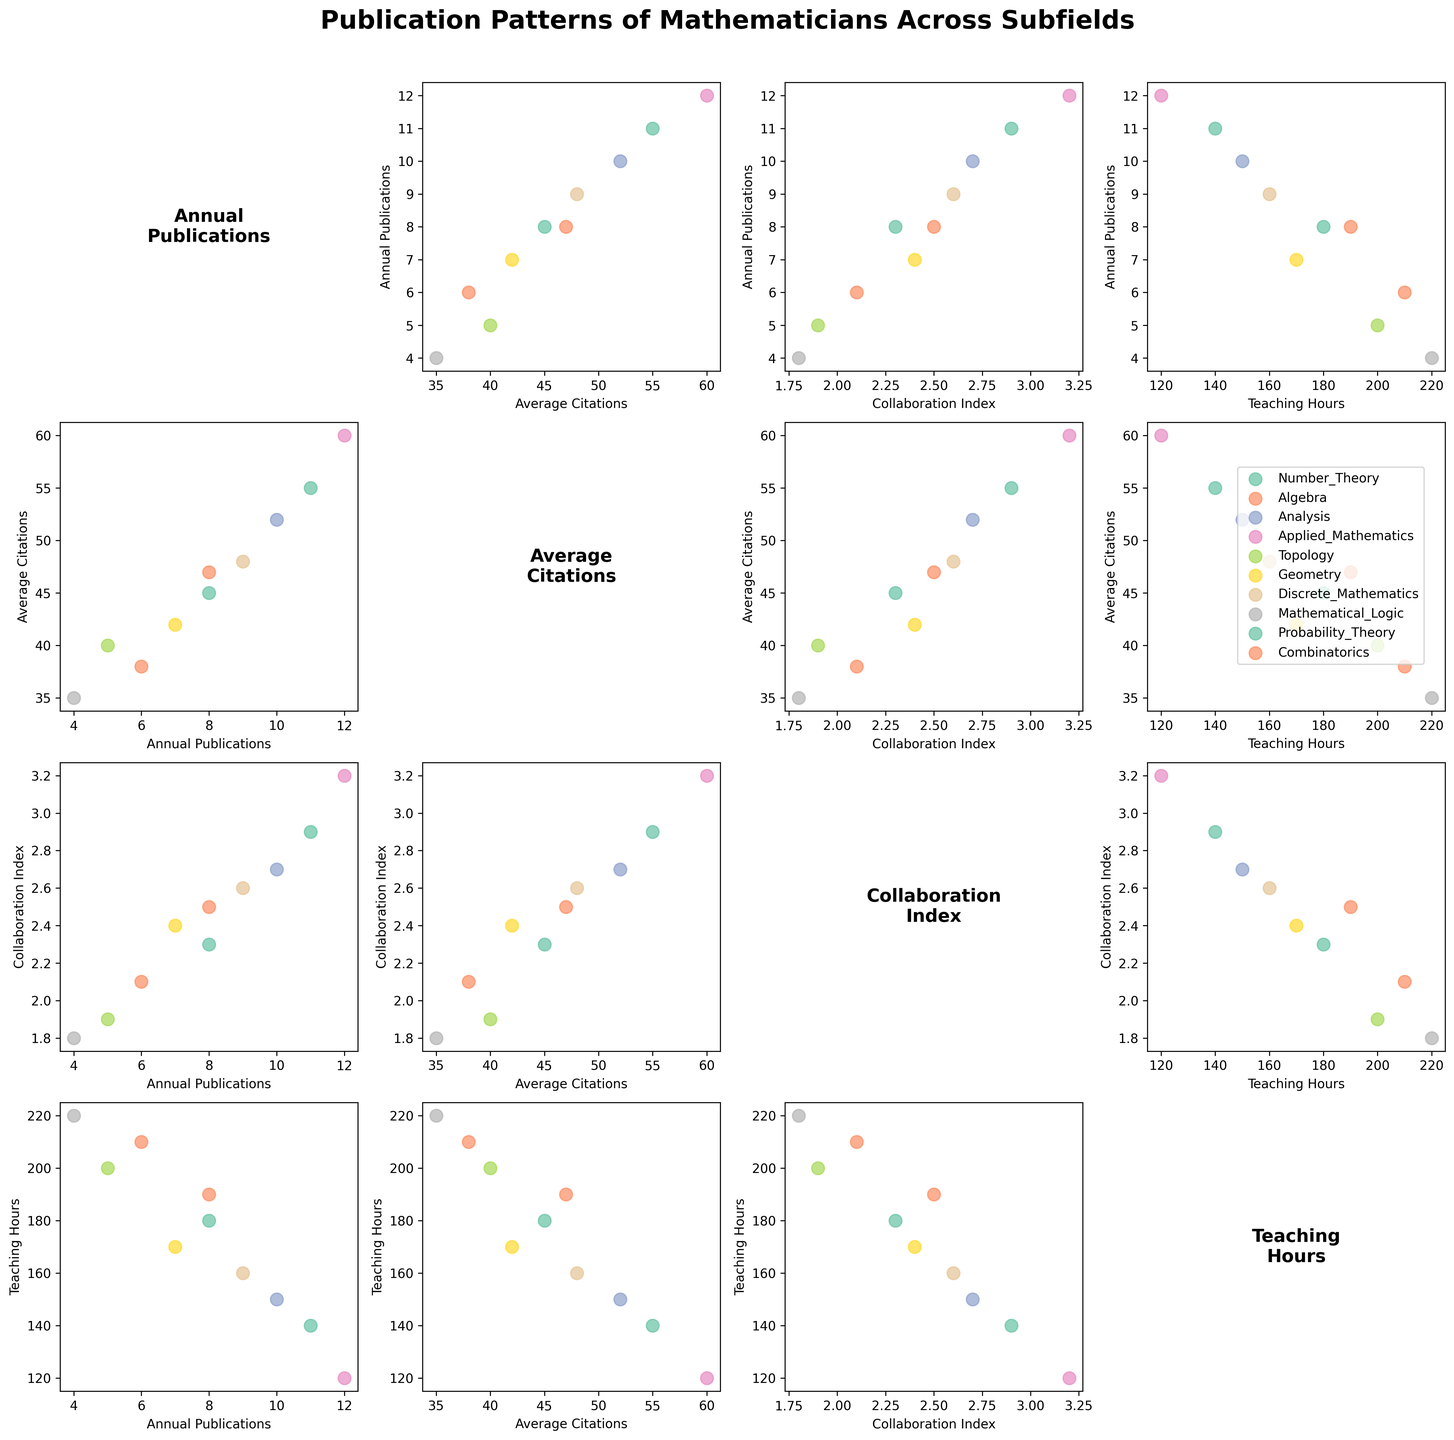what is the title of the figure? The title is found at the top of the figure in large, bold font. The title summarizes what the entire figure is about.
Answer: "Publication Patterns of Mathematicians Across Subfields" What variable is plotted along all the rows on the third column? Observe the label displayed as the x-axis label for each plot in the third column from top to bottom.
Answer: "Collaboration Index" how many data points are there for the subfield of 'Analysis' across all the plots? Each subfield, including 'Analysis', is represented as a single data point in each scatter plot, but it is repeated across multiple scatter plots. Since 'Analysis' is a subfield among ten subfields, there is one data point for 'Analysis' in each scatter plot.
Answer: 12 Which subfield has the highest number of annual publications? Identify the scatter plot where 'Annual Publications' is plotted on the y-axis. Look for the subfield with the highest data point on this axis.
Answer: "Applied Mathematics" What is the average number of 'Annual Publications' for the subfields: Probability Theory, Analysis, and Discrete Mathematics? Add the values for 'Annual Publications' for these subfields and divide by the number of subfields to get the average. (11 + 10 + 9) / 3 = 10
Answer: 10 Is there a subfield that has a high Collaboration Index but low Teaching Hours? Which one(s)? Observe scatter plots where 'Collaboration Index' is plotted against 'Teaching Hours' and look for data points where high values of 'Collaboration Index' correspond to low values of 'Teaching Hours'.
Answer: "Applied Mathematics" Which subfield has the lowest average citations and how does it compare in terms of teaching hours? Find the subfield with the lowest 'Average Citations' from the scatter plots and then observe the corresponding 'Teaching Hours' value for this subfield.
Answer: "Mathematical Logic, 220 hours" What is the relationship between 'Average Citations' and 'Annual Publications'? Are there any discernible patterns? Check scatter plots where 'Average Citations' are plotted against 'Annual Publications'. Look for any trends such as a positive correlation where higher publication rates are associated with higher citations.
Answer: "Positive Correlation" How do the subfields 'Topology' and 'Geometry' compare in terms of their Collaboration Index and Annual Publications? Observe scatter plots where 'Collaboration Index' is plotted against 'Annual Publications'. Compare the respective data points for 'Topology' and 'Geometry'.
Answer: "Topology: 5 Publications, 1.9 Index; Geometry: 7 Publications, 2.4 Index" Which variable has the most spread out values? Look across scatter plots and identify which variable shows the widest range of data points across different subfields.
Answer: "Teaching Hours" 